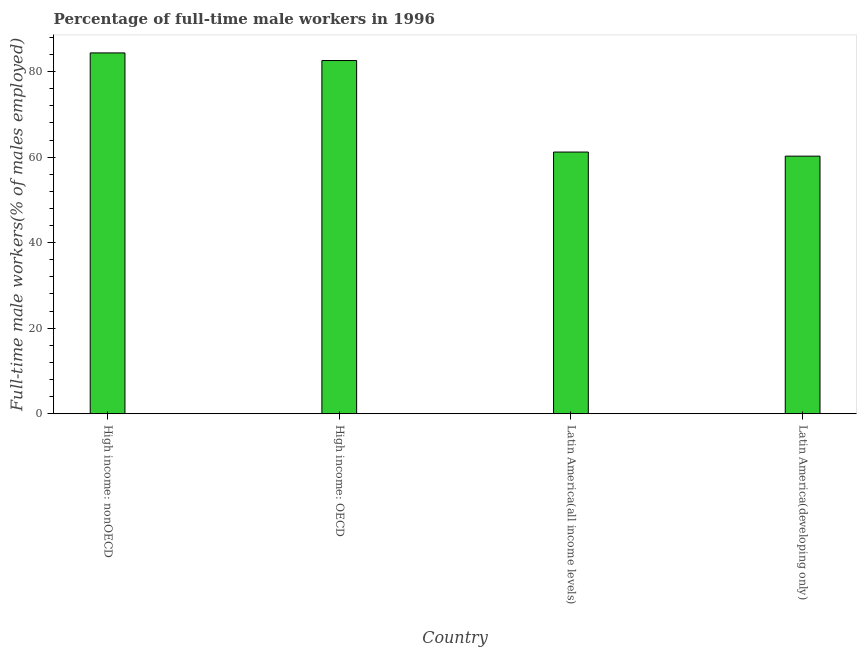Does the graph contain any zero values?
Offer a very short reply. No. What is the title of the graph?
Your response must be concise. Percentage of full-time male workers in 1996. What is the label or title of the Y-axis?
Offer a very short reply. Full-time male workers(% of males employed). What is the percentage of full-time male workers in High income: OECD?
Your answer should be very brief. 82.59. Across all countries, what is the maximum percentage of full-time male workers?
Provide a succinct answer. 84.37. Across all countries, what is the minimum percentage of full-time male workers?
Provide a short and direct response. 60.23. In which country was the percentage of full-time male workers maximum?
Give a very brief answer. High income: nonOECD. In which country was the percentage of full-time male workers minimum?
Your answer should be compact. Latin America(developing only). What is the sum of the percentage of full-time male workers?
Keep it short and to the point. 288.38. What is the difference between the percentage of full-time male workers in High income: nonOECD and Latin America(developing only)?
Your answer should be very brief. 24.14. What is the average percentage of full-time male workers per country?
Make the answer very short. 72.09. What is the median percentage of full-time male workers?
Offer a terse response. 71.89. What is the ratio of the percentage of full-time male workers in Latin America(all income levels) to that in Latin America(developing only)?
Make the answer very short. 1.02. What is the difference between the highest and the second highest percentage of full-time male workers?
Make the answer very short. 1.78. What is the difference between the highest and the lowest percentage of full-time male workers?
Make the answer very short. 24.14. In how many countries, is the percentage of full-time male workers greater than the average percentage of full-time male workers taken over all countries?
Give a very brief answer. 2. Are all the bars in the graph horizontal?
Provide a short and direct response. No. How many countries are there in the graph?
Your answer should be compact. 4. Are the values on the major ticks of Y-axis written in scientific E-notation?
Provide a short and direct response. No. What is the Full-time male workers(% of males employed) of High income: nonOECD?
Offer a very short reply. 84.37. What is the Full-time male workers(% of males employed) of High income: OECD?
Provide a short and direct response. 82.59. What is the Full-time male workers(% of males employed) of Latin America(all income levels)?
Your answer should be very brief. 61.19. What is the Full-time male workers(% of males employed) in Latin America(developing only)?
Provide a succinct answer. 60.23. What is the difference between the Full-time male workers(% of males employed) in High income: nonOECD and High income: OECD?
Offer a terse response. 1.78. What is the difference between the Full-time male workers(% of males employed) in High income: nonOECD and Latin America(all income levels)?
Keep it short and to the point. 23.18. What is the difference between the Full-time male workers(% of males employed) in High income: nonOECD and Latin America(developing only)?
Give a very brief answer. 24.14. What is the difference between the Full-time male workers(% of males employed) in High income: OECD and Latin America(all income levels)?
Your response must be concise. 21.4. What is the difference between the Full-time male workers(% of males employed) in High income: OECD and Latin America(developing only)?
Provide a short and direct response. 22.36. What is the difference between the Full-time male workers(% of males employed) in Latin America(all income levels) and Latin America(developing only)?
Make the answer very short. 0.96. What is the ratio of the Full-time male workers(% of males employed) in High income: nonOECD to that in High income: OECD?
Provide a succinct answer. 1.02. What is the ratio of the Full-time male workers(% of males employed) in High income: nonOECD to that in Latin America(all income levels)?
Provide a short and direct response. 1.38. What is the ratio of the Full-time male workers(% of males employed) in High income: nonOECD to that in Latin America(developing only)?
Keep it short and to the point. 1.4. What is the ratio of the Full-time male workers(% of males employed) in High income: OECD to that in Latin America(all income levels)?
Provide a short and direct response. 1.35. What is the ratio of the Full-time male workers(% of males employed) in High income: OECD to that in Latin America(developing only)?
Provide a short and direct response. 1.37. 